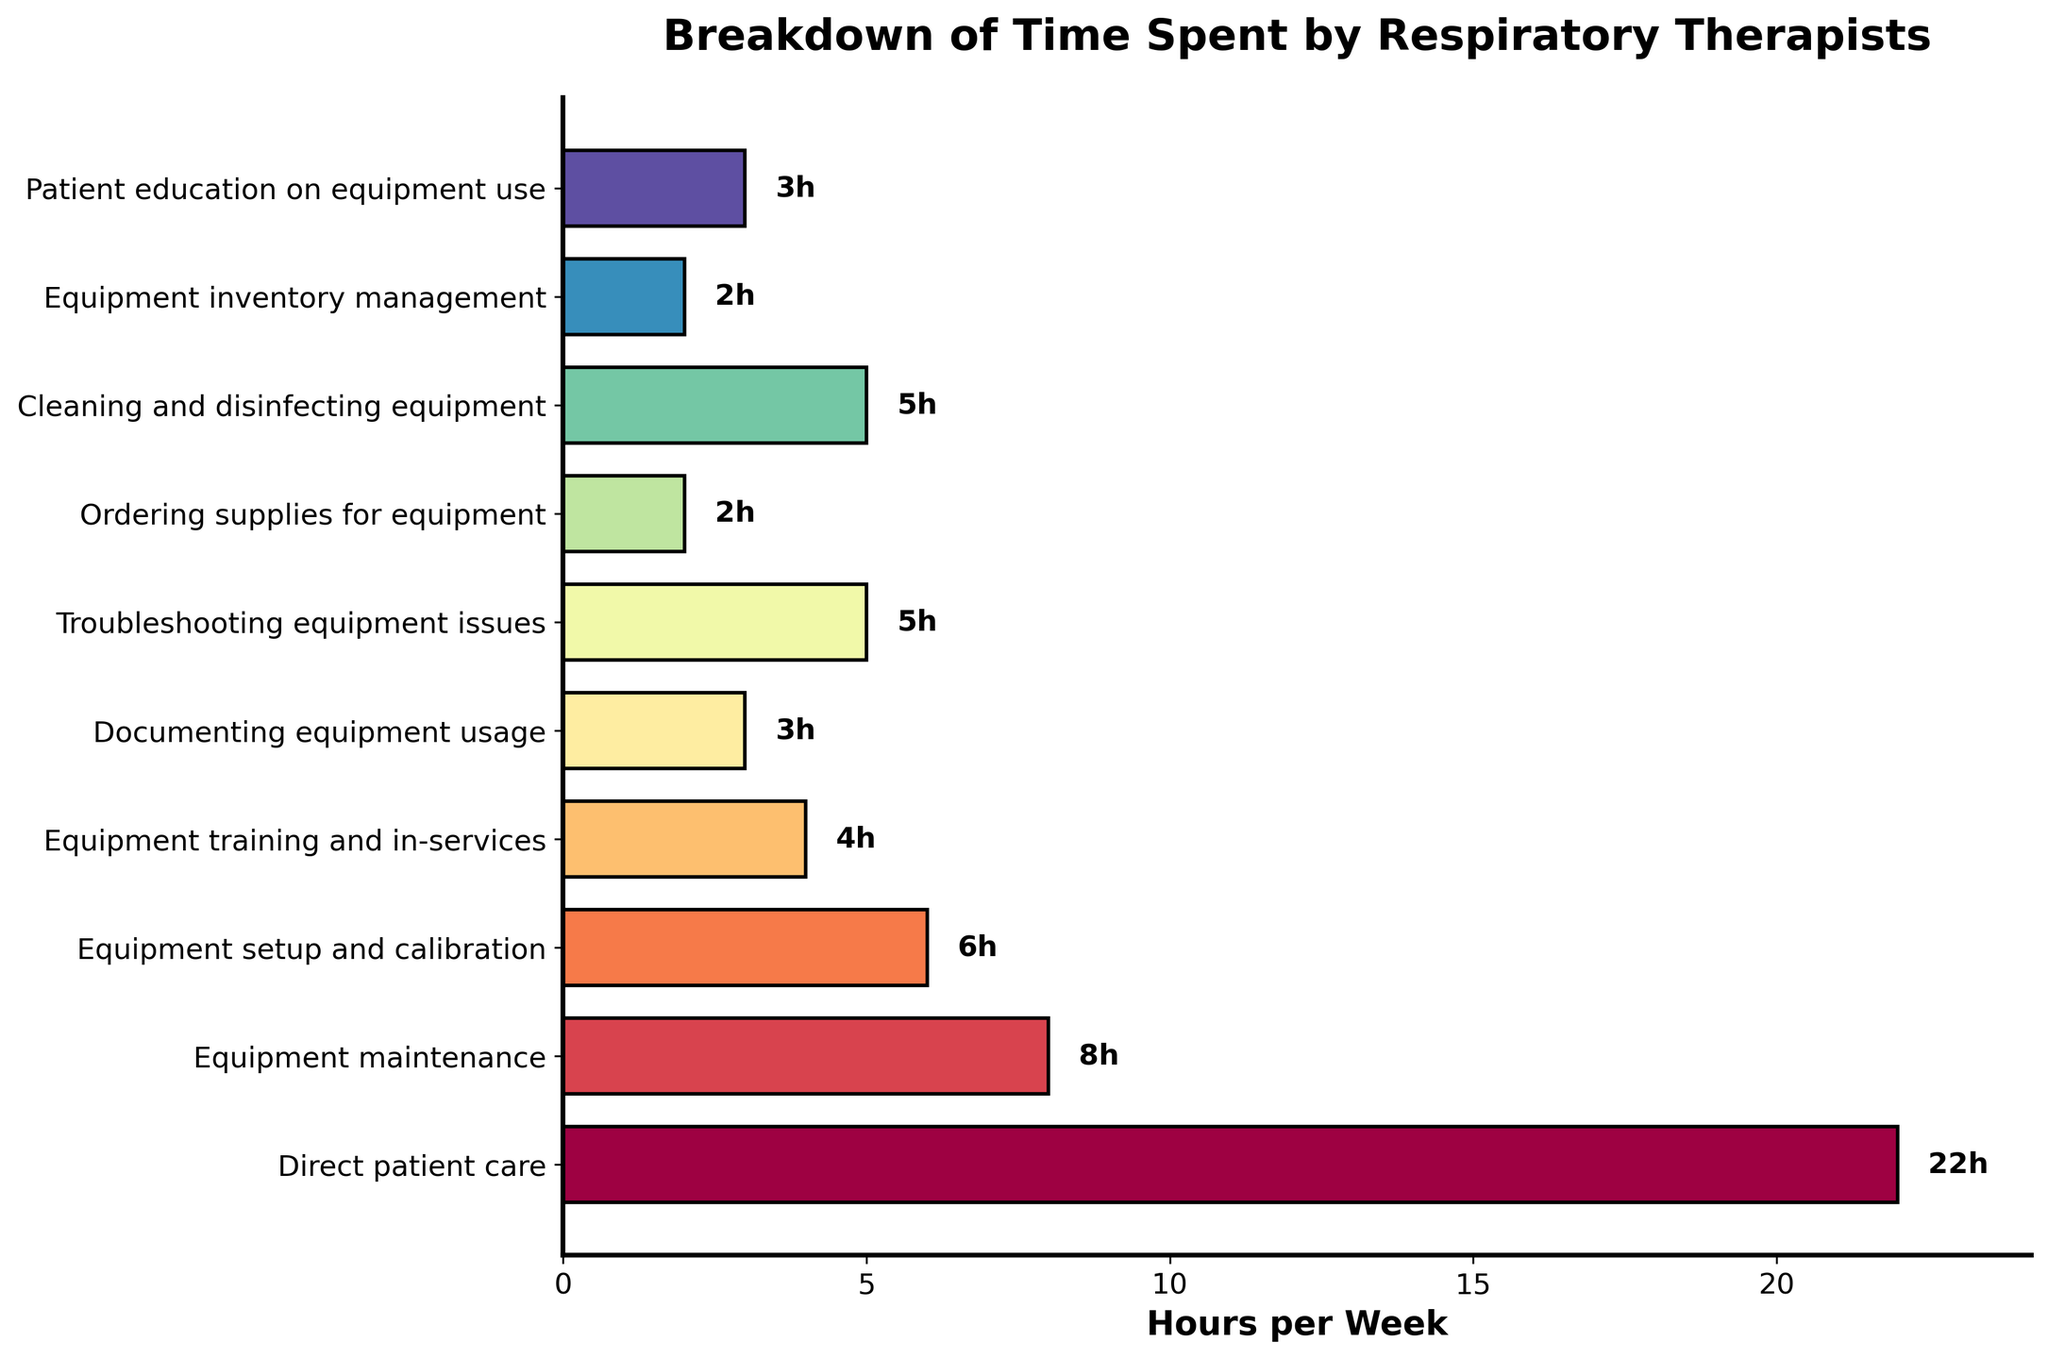How many total hours are spent on equipment-related tasks? We add all the hours spent on equipment-related tasks: 8 (Equipment maintenance) + 6 (Equipment setup and calibration) + 4 (Equipment training and in-services) + 3 (Documenting equipment usage) + 5 (Troubleshooting equipment issues) + 2 (Ordering supplies for equipment) + 5 (Cleaning and disinfecting equipment) + 2 (Equipment inventory management) + 3 (Patient education on equipment use). Total = 38 hours.
Answer: 38 Which task do respiratory therapists spend the most time on? The task with the longest bar is "Direct patient care" with 22 hours.
Answer: Direct patient care How much time is spent on equipment maintenance compared to equipment setup and calibration? The bar for equipment maintenance represents 8 hours, while the bar for equipment setup and calibration represents 6 hours. 8 is greater than 6.
Answer: Equipment maintenance Which equipment-related task takes the least amount of time? The tasks with the shortest bars (2 hours each) are "Ordering supplies for equipment" and "Equipment inventory management."
Answer: Ordering supplies for equipment and Equipment inventory management If you combine the time spent on documenting and troubleshooting equipment, how does it compare to the time spent on cleaning and disinfecting equipment? Documenting equipment usage takes 3 hours and troubleshooting equipment takes 5 hours. Combined, they take 3 + 5 = 8 hours. Cleaning and disinfecting equipment takes 5 hours, which is less than 8 hours.
Answer: 8 hours, which is more What is the average time spent on troubleshooting equipment issues, ordering supplies for equipment, and cleaning and disinfecting equipment? The time spent on each task are: 5 hours (troubleshooting), 2 hours (ordering supplies), and 5 hours (cleaning and disinfecting). The average time is calculated as (5 + 2 + 5) / 3 = 4 hours.
Answer: 4 hours Which color represents the task of equipment setup and calibration, and how can you identify it visually? The task "Equipment setup and calibration" is represented by the second bar from the bottom, which has a distinctive color assigned from the cm.Spectral colormap.
Answer: Light purple (from the data order) Which task takes exactly 3 hours, and what is their combined contribution to the total weekly time spent? The tasks that take exactly 3 hours are "Documenting equipment usage" and "Patient education on equipment use." Combined, they contribute 3 + 3 = 6 hours.
Answer: Documenting equipment usage and Patient education on equipment use, 6 hours Is the time spent on equipment training and in-services greater than, less than, or equal to the time spent on patient education on equipment use? The bars show 4 hours for equipment training and in-services and 3 hours for patient education on equipment use. Therefore, 4 is greater than 3.
Answer: Greater than Considering only the equipment-related tasks, which task is allocated the most time, and how does it compare to the time spent on equipment inventory management? The equipment-related task allocated the most time is "Equipment maintenance" with 8 hours. This is compared to "Equipment inventory management" which takes 2 hours. Therefore, 8 hours is greater than 2 hours.
Answer: Equipment maintenance, greater than 